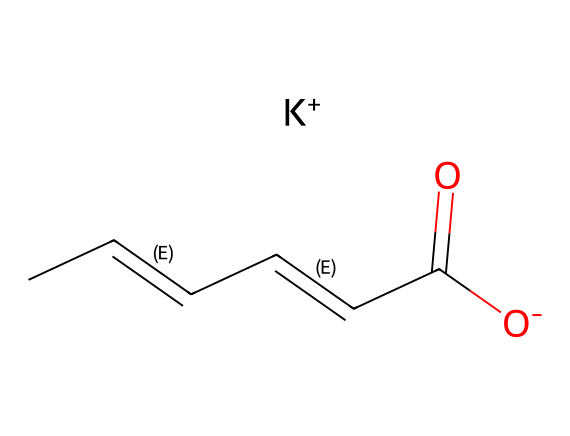How many carbon atoms are present in potassium sorbate? The SMILES representation shows a chain of carbon atoms with the "C" denoting carbon. Counting the number of "C" symbols gives a total of five carbon atoms.
Answer: five What is the functional group present in potassium sorbate? Looking at the structure, the "C(=O)[O-]" portion indicates a carboxylate group, which is characteristic of a carboxylic acid but here exists as a deprotonated form (salt).
Answer: carboxylate How many double bonds are in the structure of potassium sorbate? The "/C=C/" notation indicates double bonds between adjacent carbon atoms. There are two such occurrences in the SMILES, indicating two double bonds in total.
Answer: two What is the charge on the potassium ion in potassium sorbate? In the SMILES representation, "[K+]" indicates that the potassium ion carries a positive charge.
Answer: positive What is the role of potassium sorbate in food preservation? Potassium sorbate inhibits the growth of mold, yeast, and some bacteria, extending the shelf life of food products.
Answer: inhibition of growth Does potassium sorbate have a significant impact on flavor or aroma in food? Generally, potassium sorbate is used in low concentrations and does not contribute to flavor or aroma, allowing the natural taste of food to be maintained.
Answer: no impact 